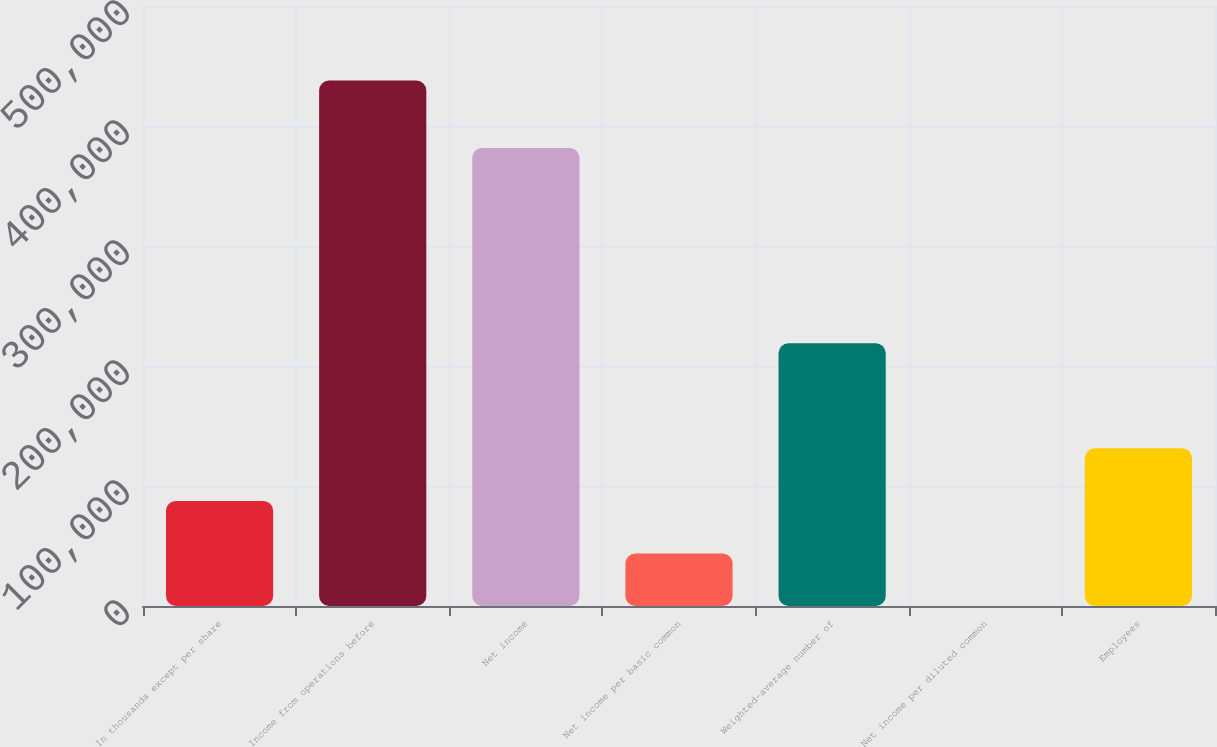<chart> <loc_0><loc_0><loc_500><loc_500><bar_chart><fcel>In thousands except per share<fcel>Income from operations before<fcel>Net income<fcel>Net income per basic common<fcel>Weighted-average number of<fcel>Net income per diluted common<fcel>Employees<nl><fcel>87575.8<fcel>437863<fcel>381763<fcel>43789.9<fcel>218934<fcel>4.06<fcel>131362<nl></chart> 